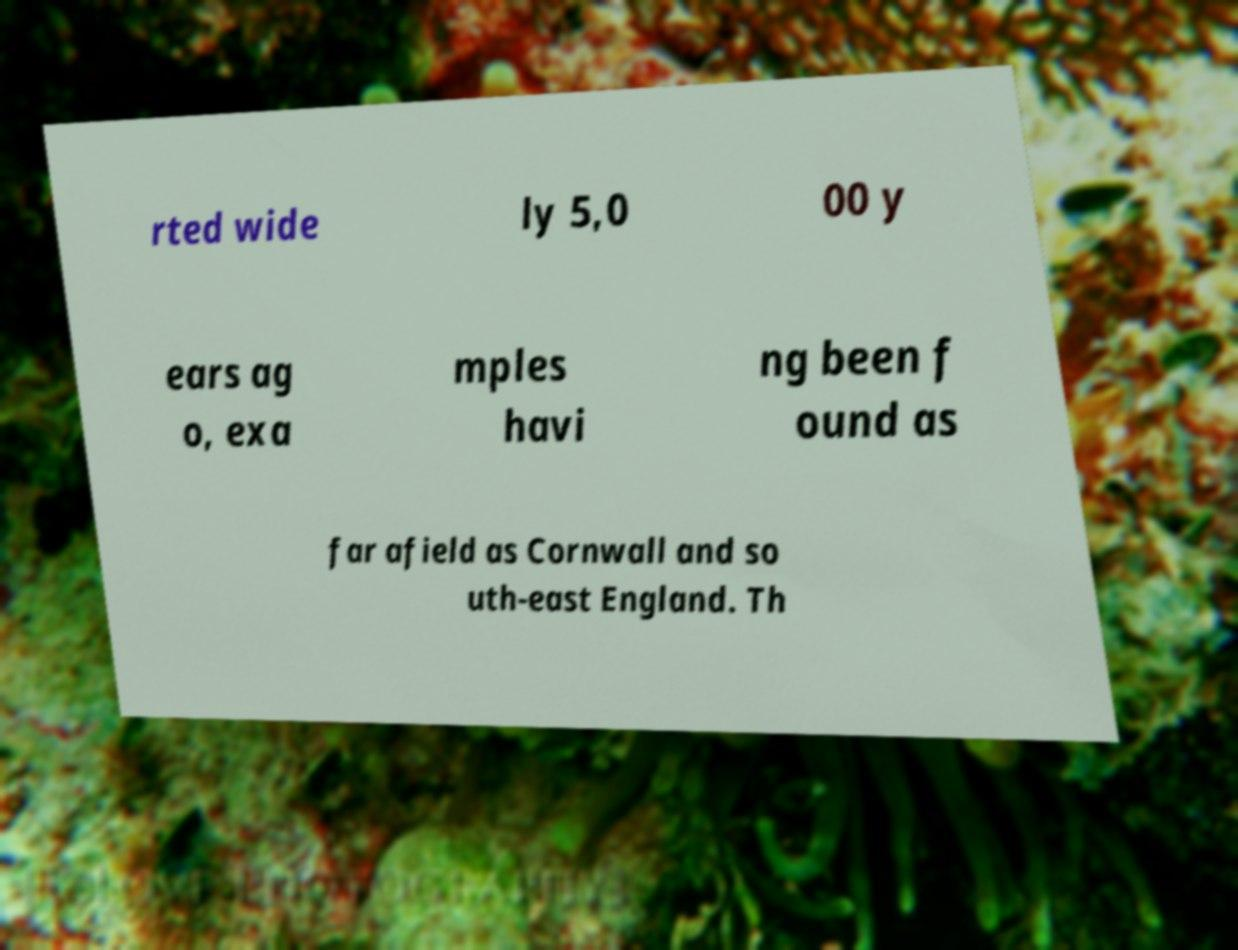There's text embedded in this image that I need extracted. Can you transcribe it verbatim? rted wide ly 5,0 00 y ears ag o, exa mples havi ng been f ound as far afield as Cornwall and so uth-east England. Th 